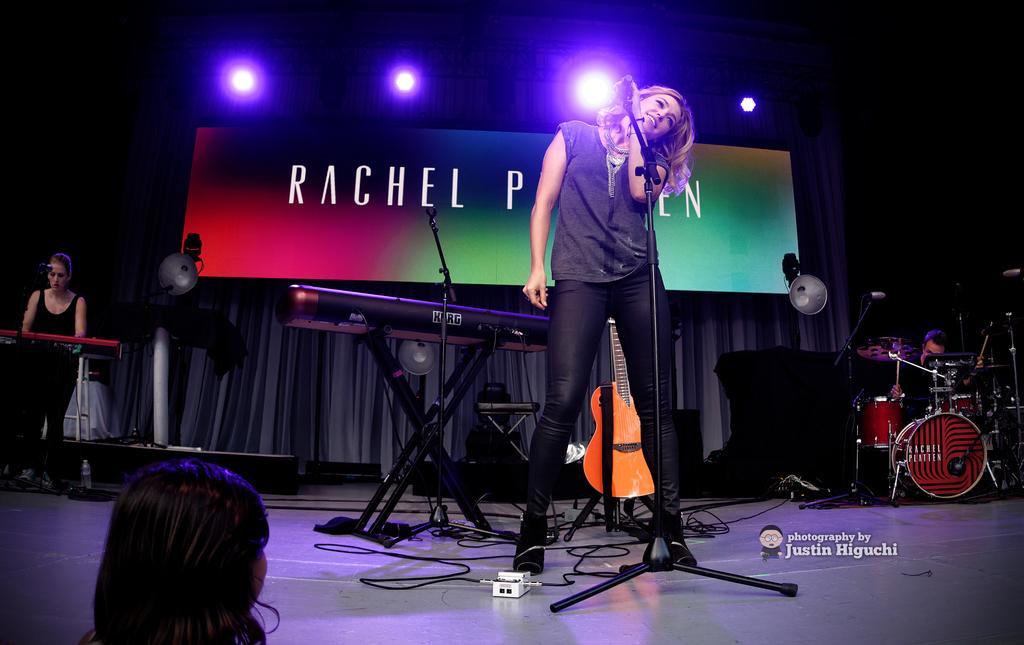In one or two sentences, can you explain what this image depicts? Here is the woman standing and smiling. She is holding a mike. This is the mike stand. I can see a piano and guitar behind the women. Here is the person sitting and playing drums and here is another person at left side is standing and playing piano. This looks like a banner with name on it. These are the show lights. I can see a cloth hanging. 